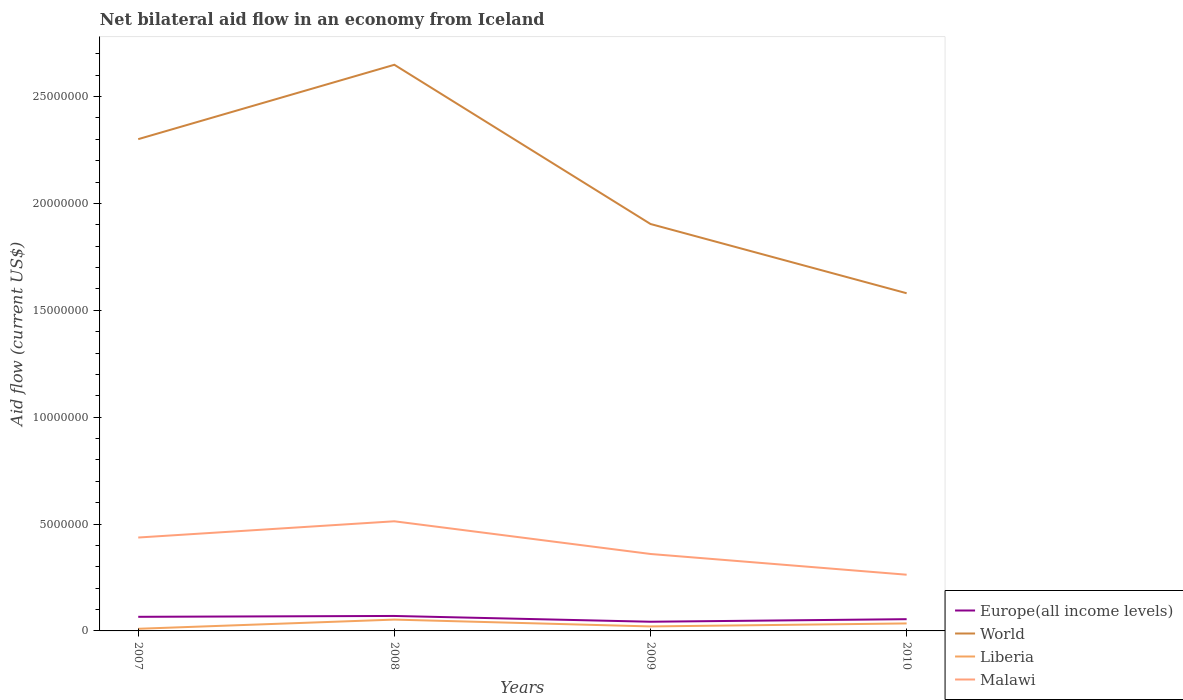How many different coloured lines are there?
Your answer should be compact. 4. Is the number of lines equal to the number of legend labels?
Offer a terse response. Yes. Across all years, what is the maximum net bilateral aid flow in World?
Your answer should be compact. 1.58e+07. In which year was the net bilateral aid flow in Europe(all income levels) maximum?
Your answer should be compact. 2009. What is the difference between the highest and the second highest net bilateral aid flow in World?
Ensure brevity in your answer.  1.07e+07. What is the difference between the highest and the lowest net bilateral aid flow in Malawi?
Provide a succinct answer. 2. How many lines are there?
Ensure brevity in your answer.  4. How many years are there in the graph?
Your answer should be very brief. 4. What is the difference between two consecutive major ticks on the Y-axis?
Offer a very short reply. 5.00e+06. Are the values on the major ticks of Y-axis written in scientific E-notation?
Keep it short and to the point. No. Where does the legend appear in the graph?
Ensure brevity in your answer.  Bottom right. How many legend labels are there?
Offer a terse response. 4. How are the legend labels stacked?
Your response must be concise. Vertical. What is the title of the graph?
Offer a terse response. Net bilateral aid flow in an economy from Iceland. What is the Aid flow (current US$) in World in 2007?
Your response must be concise. 2.30e+07. What is the Aid flow (current US$) of Malawi in 2007?
Your answer should be very brief. 4.37e+06. What is the Aid flow (current US$) in Europe(all income levels) in 2008?
Provide a short and direct response. 7.00e+05. What is the Aid flow (current US$) of World in 2008?
Give a very brief answer. 2.65e+07. What is the Aid flow (current US$) of Liberia in 2008?
Offer a very short reply. 5.30e+05. What is the Aid flow (current US$) in Malawi in 2008?
Ensure brevity in your answer.  5.13e+06. What is the Aid flow (current US$) of Europe(all income levels) in 2009?
Offer a terse response. 4.30e+05. What is the Aid flow (current US$) of World in 2009?
Offer a very short reply. 1.90e+07. What is the Aid flow (current US$) in Liberia in 2009?
Ensure brevity in your answer.  2.10e+05. What is the Aid flow (current US$) of Malawi in 2009?
Provide a succinct answer. 3.60e+06. What is the Aid flow (current US$) in Europe(all income levels) in 2010?
Ensure brevity in your answer.  5.50e+05. What is the Aid flow (current US$) in World in 2010?
Your response must be concise. 1.58e+07. What is the Aid flow (current US$) in Liberia in 2010?
Your answer should be compact. 3.50e+05. What is the Aid flow (current US$) of Malawi in 2010?
Your answer should be compact. 2.63e+06. Across all years, what is the maximum Aid flow (current US$) in Europe(all income levels)?
Offer a very short reply. 7.00e+05. Across all years, what is the maximum Aid flow (current US$) of World?
Give a very brief answer. 2.65e+07. Across all years, what is the maximum Aid flow (current US$) in Liberia?
Provide a short and direct response. 5.30e+05. Across all years, what is the maximum Aid flow (current US$) in Malawi?
Offer a terse response. 5.13e+06. Across all years, what is the minimum Aid flow (current US$) of Europe(all income levels)?
Keep it short and to the point. 4.30e+05. Across all years, what is the minimum Aid flow (current US$) in World?
Your response must be concise. 1.58e+07. Across all years, what is the minimum Aid flow (current US$) of Liberia?
Your response must be concise. 1.00e+05. Across all years, what is the minimum Aid flow (current US$) of Malawi?
Give a very brief answer. 2.63e+06. What is the total Aid flow (current US$) in Europe(all income levels) in the graph?
Your answer should be compact. 2.34e+06. What is the total Aid flow (current US$) in World in the graph?
Keep it short and to the point. 8.43e+07. What is the total Aid flow (current US$) in Liberia in the graph?
Make the answer very short. 1.19e+06. What is the total Aid flow (current US$) in Malawi in the graph?
Offer a terse response. 1.57e+07. What is the difference between the Aid flow (current US$) of World in 2007 and that in 2008?
Your response must be concise. -3.48e+06. What is the difference between the Aid flow (current US$) in Liberia in 2007 and that in 2008?
Provide a short and direct response. -4.30e+05. What is the difference between the Aid flow (current US$) in Malawi in 2007 and that in 2008?
Offer a terse response. -7.60e+05. What is the difference between the Aid flow (current US$) of Europe(all income levels) in 2007 and that in 2009?
Make the answer very short. 2.30e+05. What is the difference between the Aid flow (current US$) of World in 2007 and that in 2009?
Your response must be concise. 3.97e+06. What is the difference between the Aid flow (current US$) in Malawi in 2007 and that in 2009?
Provide a succinct answer. 7.70e+05. What is the difference between the Aid flow (current US$) of Europe(all income levels) in 2007 and that in 2010?
Your response must be concise. 1.10e+05. What is the difference between the Aid flow (current US$) in World in 2007 and that in 2010?
Keep it short and to the point. 7.21e+06. What is the difference between the Aid flow (current US$) in Malawi in 2007 and that in 2010?
Give a very brief answer. 1.74e+06. What is the difference between the Aid flow (current US$) in World in 2008 and that in 2009?
Make the answer very short. 7.45e+06. What is the difference between the Aid flow (current US$) in Liberia in 2008 and that in 2009?
Provide a succinct answer. 3.20e+05. What is the difference between the Aid flow (current US$) in Malawi in 2008 and that in 2009?
Give a very brief answer. 1.53e+06. What is the difference between the Aid flow (current US$) of World in 2008 and that in 2010?
Provide a succinct answer. 1.07e+07. What is the difference between the Aid flow (current US$) in Liberia in 2008 and that in 2010?
Offer a very short reply. 1.80e+05. What is the difference between the Aid flow (current US$) of Malawi in 2008 and that in 2010?
Make the answer very short. 2.50e+06. What is the difference between the Aid flow (current US$) in World in 2009 and that in 2010?
Your answer should be very brief. 3.24e+06. What is the difference between the Aid flow (current US$) in Liberia in 2009 and that in 2010?
Your answer should be compact. -1.40e+05. What is the difference between the Aid flow (current US$) in Malawi in 2009 and that in 2010?
Keep it short and to the point. 9.70e+05. What is the difference between the Aid flow (current US$) in Europe(all income levels) in 2007 and the Aid flow (current US$) in World in 2008?
Give a very brief answer. -2.58e+07. What is the difference between the Aid flow (current US$) in Europe(all income levels) in 2007 and the Aid flow (current US$) in Liberia in 2008?
Provide a succinct answer. 1.30e+05. What is the difference between the Aid flow (current US$) of Europe(all income levels) in 2007 and the Aid flow (current US$) of Malawi in 2008?
Make the answer very short. -4.47e+06. What is the difference between the Aid flow (current US$) in World in 2007 and the Aid flow (current US$) in Liberia in 2008?
Your response must be concise. 2.25e+07. What is the difference between the Aid flow (current US$) in World in 2007 and the Aid flow (current US$) in Malawi in 2008?
Keep it short and to the point. 1.79e+07. What is the difference between the Aid flow (current US$) in Liberia in 2007 and the Aid flow (current US$) in Malawi in 2008?
Keep it short and to the point. -5.03e+06. What is the difference between the Aid flow (current US$) in Europe(all income levels) in 2007 and the Aid flow (current US$) in World in 2009?
Your answer should be very brief. -1.84e+07. What is the difference between the Aid flow (current US$) in Europe(all income levels) in 2007 and the Aid flow (current US$) in Liberia in 2009?
Your response must be concise. 4.50e+05. What is the difference between the Aid flow (current US$) in Europe(all income levels) in 2007 and the Aid flow (current US$) in Malawi in 2009?
Offer a very short reply. -2.94e+06. What is the difference between the Aid flow (current US$) in World in 2007 and the Aid flow (current US$) in Liberia in 2009?
Your response must be concise. 2.28e+07. What is the difference between the Aid flow (current US$) in World in 2007 and the Aid flow (current US$) in Malawi in 2009?
Make the answer very short. 1.94e+07. What is the difference between the Aid flow (current US$) in Liberia in 2007 and the Aid flow (current US$) in Malawi in 2009?
Ensure brevity in your answer.  -3.50e+06. What is the difference between the Aid flow (current US$) in Europe(all income levels) in 2007 and the Aid flow (current US$) in World in 2010?
Your answer should be compact. -1.51e+07. What is the difference between the Aid flow (current US$) in Europe(all income levels) in 2007 and the Aid flow (current US$) in Liberia in 2010?
Make the answer very short. 3.10e+05. What is the difference between the Aid flow (current US$) in Europe(all income levels) in 2007 and the Aid flow (current US$) in Malawi in 2010?
Ensure brevity in your answer.  -1.97e+06. What is the difference between the Aid flow (current US$) of World in 2007 and the Aid flow (current US$) of Liberia in 2010?
Your answer should be very brief. 2.27e+07. What is the difference between the Aid flow (current US$) in World in 2007 and the Aid flow (current US$) in Malawi in 2010?
Give a very brief answer. 2.04e+07. What is the difference between the Aid flow (current US$) of Liberia in 2007 and the Aid flow (current US$) of Malawi in 2010?
Give a very brief answer. -2.53e+06. What is the difference between the Aid flow (current US$) in Europe(all income levels) in 2008 and the Aid flow (current US$) in World in 2009?
Your answer should be compact. -1.83e+07. What is the difference between the Aid flow (current US$) of Europe(all income levels) in 2008 and the Aid flow (current US$) of Liberia in 2009?
Give a very brief answer. 4.90e+05. What is the difference between the Aid flow (current US$) of Europe(all income levels) in 2008 and the Aid flow (current US$) of Malawi in 2009?
Make the answer very short. -2.90e+06. What is the difference between the Aid flow (current US$) in World in 2008 and the Aid flow (current US$) in Liberia in 2009?
Give a very brief answer. 2.63e+07. What is the difference between the Aid flow (current US$) of World in 2008 and the Aid flow (current US$) of Malawi in 2009?
Offer a very short reply. 2.29e+07. What is the difference between the Aid flow (current US$) of Liberia in 2008 and the Aid flow (current US$) of Malawi in 2009?
Provide a short and direct response. -3.07e+06. What is the difference between the Aid flow (current US$) of Europe(all income levels) in 2008 and the Aid flow (current US$) of World in 2010?
Your response must be concise. -1.51e+07. What is the difference between the Aid flow (current US$) of Europe(all income levels) in 2008 and the Aid flow (current US$) of Liberia in 2010?
Provide a short and direct response. 3.50e+05. What is the difference between the Aid flow (current US$) in Europe(all income levels) in 2008 and the Aid flow (current US$) in Malawi in 2010?
Offer a very short reply. -1.93e+06. What is the difference between the Aid flow (current US$) of World in 2008 and the Aid flow (current US$) of Liberia in 2010?
Give a very brief answer. 2.61e+07. What is the difference between the Aid flow (current US$) of World in 2008 and the Aid flow (current US$) of Malawi in 2010?
Offer a very short reply. 2.39e+07. What is the difference between the Aid flow (current US$) of Liberia in 2008 and the Aid flow (current US$) of Malawi in 2010?
Your response must be concise. -2.10e+06. What is the difference between the Aid flow (current US$) of Europe(all income levels) in 2009 and the Aid flow (current US$) of World in 2010?
Make the answer very short. -1.54e+07. What is the difference between the Aid flow (current US$) in Europe(all income levels) in 2009 and the Aid flow (current US$) in Liberia in 2010?
Your answer should be very brief. 8.00e+04. What is the difference between the Aid flow (current US$) of Europe(all income levels) in 2009 and the Aid flow (current US$) of Malawi in 2010?
Your answer should be very brief. -2.20e+06. What is the difference between the Aid flow (current US$) of World in 2009 and the Aid flow (current US$) of Liberia in 2010?
Your response must be concise. 1.87e+07. What is the difference between the Aid flow (current US$) in World in 2009 and the Aid flow (current US$) in Malawi in 2010?
Give a very brief answer. 1.64e+07. What is the difference between the Aid flow (current US$) of Liberia in 2009 and the Aid flow (current US$) of Malawi in 2010?
Give a very brief answer. -2.42e+06. What is the average Aid flow (current US$) of Europe(all income levels) per year?
Offer a terse response. 5.85e+05. What is the average Aid flow (current US$) in World per year?
Provide a succinct answer. 2.11e+07. What is the average Aid flow (current US$) in Liberia per year?
Ensure brevity in your answer.  2.98e+05. What is the average Aid flow (current US$) of Malawi per year?
Provide a short and direct response. 3.93e+06. In the year 2007, what is the difference between the Aid flow (current US$) in Europe(all income levels) and Aid flow (current US$) in World?
Provide a succinct answer. -2.24e+07. In the year 2007, what is the difference between the Aid flow (current US$) in Europe(all income levels) and Aid flow (current US$) in Liberia?
Give a very brief answer. 5.60e+05. In the year 2007, what is the difference between the Aid flow (current US$) in Europe(all income levels) and Aid flow (current US$) in Malawi?
Ensure brevity in your answer.  -3.71e+06. In the year 2007, what is the difference between the Aid flow (current US$) in World and Aid flow (current US$) in Liberia?
Offer a very short reply. 2.29e+07. In the year 2007, what is the difference between the Aid flow (current US$) of World and Aid flow (current US$) of Malawi?
Your response must be concise. 1.86e+07. In the year 2007, what is the difference between the Aid flow (current US$) in Liberia and Aid flow (current US$) in Malawi?
Provide a succinct answer. -4.27e+06. In the year 2008, what is the difference between the Aid flow (current US$) in Europe(all income levels) and Aid flow (current US$) in World?
Offer a very short reply. -2.58e+07. In the year 2008, what is the difference between the Aid flow (current US$) of Europe(all income levels) and Aid flow (current US$) of Malawi?
Give a very brief answer. -4.43e+06. In the year 2008, what is the difference between the Aid flow (current US$) in World and Aid flow (current US$) in Liberia?
Give a very brief answer. 2.60e+07. In the year 2008, what is the difference between the Aid flow (current US$) in World and Aid flow (current US$) in Malawi?
Keep it short and to the point. 2.14e+07. In the year 2008, what is the difference between the Aid flow (current US$) of Liberia and Aid flow (current US$) of Malawi?
Offer a very short reply. -4.60e+06. In the year 2009, what is the difference between the Aid flow (current US$) in Europe(all income levels) and Aid flow (current US$) in World?
Provide a short and direct response. -1.86e+07. In the year 2009, what is the difference between the Aid flow (current US$) of Europe(all income levels) and Aid flow (current US$) of Liberia?
Your answer should be compact. 2.20e+05. In the year 2009, what is the difference between the Aid flow (current US$) of Europe(all income levels) and Aid flow (current US$) of Malawi?
Offer a very short reply. -3.17e+06. In the year 2009, what is the difference between the Aid flow (current US$) in World and Aid flow (current US$) in Liberia?
Your response must be concise. 1.88e+07. In the year 2009, what is the difference between the Aid flow (current US$) of World and Aid flow (current US$) of Malawi?
Make the answer very short. 1.54e+07. In the year 2009, what is the difference between the Aid flow (current US$) in Liberia and Aid flow (current US$) in Malawi?
Provide a short and direct response. -3.39e+06. In the year 2010, what is the difference between the Aid flow (current US$) of Europe(all income levels) and Aid flow (current US$) of World?
Ensure brevity in your answer.  -1.52e+07. In the year 2010, what is the difference between the Aid flow (current US$) in Europe(all income levels) and Aid flow (current US$) in Malawi?
Provide a succinct answer. -2.08e+06. In the year 2010, what is the difference between the Aid flow (current US$) in World and Aid flow (current US$) in Liberia?
Offer a very short reply. 1.54e+07. In the year 2010, what is the difference between the Aid flow (current US$) in World and Aid flow (current US$) in Malawi?
Ensure brevity in your answer.  1.32e+07. In the year 2010, what is the difference between the Aid flow (current US$) of Liberia and Aid flow (current US$) of Malawi?
Keep it short and to the point. -2.28e+06. What is the ratio of the Aid flow (current US$) in Europe(all income levels) in 2007 to that in 2008?
Offer a very short reply. 0.94. What is the ratio of the Aid flow (current US$) of World in 2007 to that in 2008?
Keep it short and to the point. 0.87. What is the ratio of the Aid flow (current US$) of Liberia in 2007 to that in 2008?
Keep it short and to the point. 0.19. What is the ratio of the Aid flow (current US$) of Malawi in 2007 to that in 2008?
Provide a short and direct response. 0.85. What is the ratio of the Aid flow (current US$) in Europe(all income levels) in 2007 to that in 2009?
Your answer should be very brief. 1.53. What is the ratio of the Aid flow (current US$) of World in 2007 to that in 2009?
Ensure brevity in your answer.  1.21. What is the ratio of the Aid flow (current US$) in Liberia in 2007 to that in 2009?
Offer a very short reply. 0.48. What is the ratio of the Aid flow (current US$) of Malawi in 2007 to that in 2009?
Keep it short and to the point. 1.21. What is the ratio of the Aid flow (current US$) of World in 2007 to that in 2010?
Provide a short and direct response. 1.46. What is the ratio of the Aid flow (current US$) of Liberia in 2007 to that in 2010?
Keep it short and to the point. 0.29. What is the ratio of the Aid flow (current US$) of Malawi in 2007 to that in 2010?
Your answer should be very brief. 1.66. What is the ratio of the Aid flow (current US$) of Europe(all income levels) in 2008 to that in 2009?
Give a very brief answer. 1.63. What is the ratio of the Aid flow (current US$) in World in 2008 to that in 2009?
Offer a terse response. 1.39. What is the ratio of the Aid flow (current US$) of Liberia in 2008 to that in 2009?
Your response must be concise. 2.52. What is the ratio of the Aid flow (current US$) of Malawi in 2008 to that in 2009?
Provide a succinct answer. 1.43. What is the ratio of the Aid flow (current US$) of Europe(all income levels) in 2008 to that in 2010?
Your answer should be compact. 1.27. What is the ratio of the Aid flow (current US$) in World in 2008 to that in 2010?
Provide a succinct answer. 1.68. What is the ratio of the Aid flow (current US$) in Liberia in 2008 to that in 2010?
Give a very brief answer. 1.51. What is the ratio of the Aid flow (current US$) in Malawi in 2008 to that in 2010?
Offer a terse response. 1.95. What is the ratio of the Aid flow (current US$) of Europe(all income levels) in 2009 to that in 2010?
Keep it short and to the point. 0.78. What is the ratio of the Aid flow (current US$) of World in 2009 to that in 2010?
Give a very brief answer. 1.21. What is the ratio of the Aid flow (current US$) in Malawi in 2009 to that in 2010?
Keep it short and to the point. 1.37. What is the difference between the highest and the second highest Aid flow (current US$) in World?
Offer a very short reply. 3.48e+06. What is the difference between the highest and the second highest Aid flow (current US$) of Malawi?
Your response must be concise. 7.60e+05. What is the difference between the highest and the lowest Aid flow (current US$) in Europe(all income levels)?
Make the answer very short. 2.70e+05. What is the difference between the highest and the lowest Aid flow (current US$) of World?
Offer a terse response. 1.07e+07. What is the difference between the highest and the lowest Aid flow (current US$) of Malawi?
Give a very brief answer. 2.50e+06. 